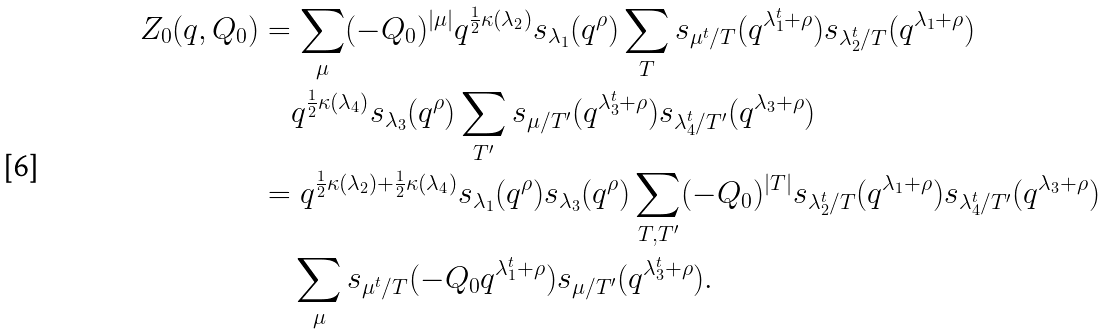Convert formula to latex. <formula><loc_0><loc_0><loc_500><loc_500>Z _ { 0 } ( q , Q _ { 0 } ) & = \sum _ { \mu } ( - Q _ { 0 } ) ^ { | \mu | } q ^ { \frac { 1 } { 2 } \kappa ( \lambda _ { 2 } ) } s _ { \lambda _ { 1 } } ( q ^ { \rho } ) \sum _ { T } s _ { \mu ^ { t } / T } ( q ^ { \lambda _ { 1 } ^ { t } + \rho } ) s _ { \lambda _ { 2 } ^ { t } / T } ( q ^ { \lambda _ { 1 } + \rho } ) \\ & \quad q ^ { \frac { 1 } { 2 } \kappa ( \lambda _ { 4 } ) } s _ { \lambda _ { 3 } } ( q ^ { \rho } ) \sum _ { T ^ { \prime } } s _ { \mu / T ^ { \prime } } ( q ^ { \lambda _ { 3 } ^ { t } + \rho } ) s _ { \lambda _ { 4 } ^ { t } / T ^ { \prime } } ( q ^ { \lambda _ { 3 } + \rho } ) \\ & = q ^ { \frac { 1 } { 2 } \kappa ( \lambda _ { 2 } ) + \frac { 1 } { 2 } \kappa ( \lambda _ { 4 } ) } s _ { \lambda _ { 1 } } ( q ^ { \rho } ) s _ { \lambda _ { 3 } } ( q ^ { \rho } ) \sum _ { T , T ^ { \prime } } ( - Q _ { 0 } ) ^ { | T | } s _ { \lambda _ { 2 } ^ { t } / T } ( q ^ { \lambda _ { 1 } + \rho } ) s _ { \lambda _ { 4 } ^ { t } / T ^ { \prime } } ( q ^ { \lambda _ { 3 } + \rho } ) \\ & \quad \sum _ { \mu } s _ { \mu ^ { t } / T } ( - Q _ { 0 } q ^ { \lambda _ { 1 } ^ { t } + \rho } ) s _ { \mu / T ^ { \prime } } ( q ^ { \lambda _ { 3 } ^ { t } + \rho } ) .</formula> 